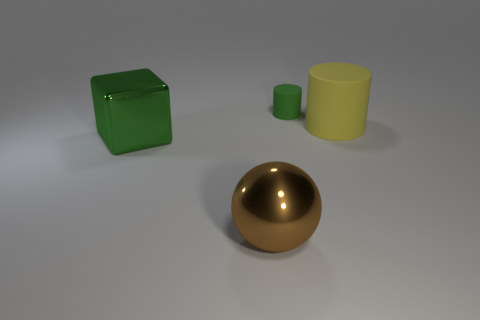Is there any other thing that has the same size as the green matte thing?
Your answer should be very brief. No. Does the ball have the same material as the green cylinder?
Give a very brief answer. No. Do the small cylinder and the big block have the same color?
Make the answer very short. Yes. What shape is the large object that is made of the same material as the green cylinder?
Keep it short and to the point. Cylinder. What number of other things are there of the same shape as the yellow rubber thing?
Provide a succinct answer. 1. There is a matte thing that is to the right of the green rubber thing; is it the same size as the small rubber cylinder?
Your response must be concise. No. Is the number of shiny cubes that are behind the large brown ball greater than the number of green balls?
Your answer should be very brief. Yes. There is a matte thing on the left side of the large yellow rubber object; what number of yellow rubber things are behind it?
Make the answer very short. 0. Are there fewer metallic blocks behind the green metal object than tiny brown metallic cubes?
Ensure brevity in your answer.  No. Are there any tiny cylinders in front of the matte thing in front of the green object that is on the right side of the metal sphere?
Your answer should be compact. No. 